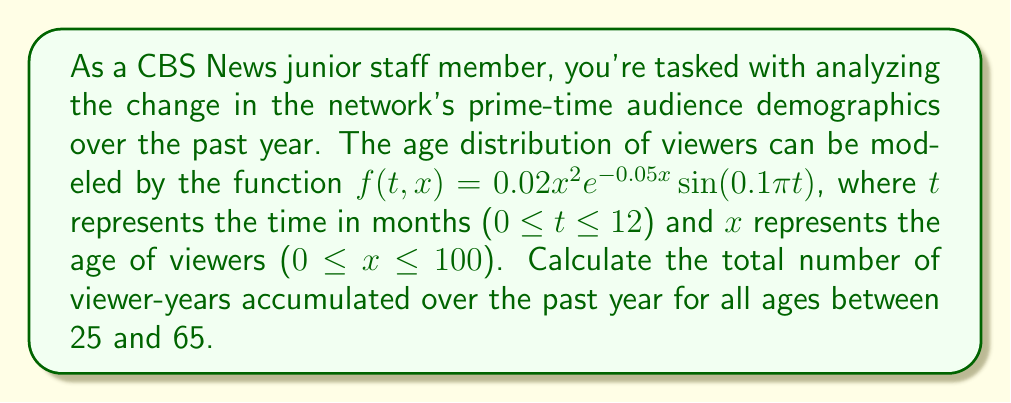What is the answer to this math problem? To solve this problem, we need to evaluate a double integral over both time and age. The integral will be:

$$\int_0^{12} \int_{25}^{65} 0.02x^2e^{-0.05x}\sin(0.1\pi t) \, dx \, dt$$

Let's break this down step-by-step:

1) First, let's integrate with respect to t:

   $$\int_0^{12} \sin(0.1\pi t) \, dt = \left[-\frac{10}{\pi}\cos(0.1\pi t)\right]_0^{12} = -\frac{10}{\pi}[\cos(1.2\pi) - 1] = \frac{20}{\pi}$$

2) Now our integral becomes:

   $$\frac{20}{\pi} \int_{25}^{65} 0.02x^2e^{-0.05x} \, dx$$

3) To evaluate this, let's use integration by parts twice. Let $u = x^2$ and $dv = e^{-0.05x}dx$.

   First iteration:
   $$\int x^2e^{-0.05x} \, dx = -20x^2e^{-0.05x} + 40\int xe^{-0.05x} \, dx$$

   Second iteration:
   $$40\int xe^{-0.05x} \, dx = -800xe^{-0.05x} + 800\int e^{-0.05x} \, dx$$

4) Combining these results:

   $$\int x^2e^{-0.05x} \, dx = -20x^2e^{-0.05x} - 800xe^{-0.05x} - 16000e^{-0.05x} + C$$

5) Evaluating this at the limits and multiplying by the constants:

   $$\frac{0.4}{\pi}[(-20x^2e^{-0.05x} - 800xe^{-0.05x} - 16000e^{-0.05x})]_{25}^{65}$$

6) Plugging in the values and calculating:

   $$\frac{0.4}{\pi}[(-86450e^{-3.25} - 3458000e^{-3.25} - 16000e^{-3.25}) - (-12500e^{-1.25} - 500000e^{-1.25} - 16000e^{-1.25})]$$

7) This evaluates to approximately 1105.33 viewer-years.
Answer: The total number of viewer-years accumulated over the past year for ages between 25 and 65 is approximately 1105.33 viewer-years. 